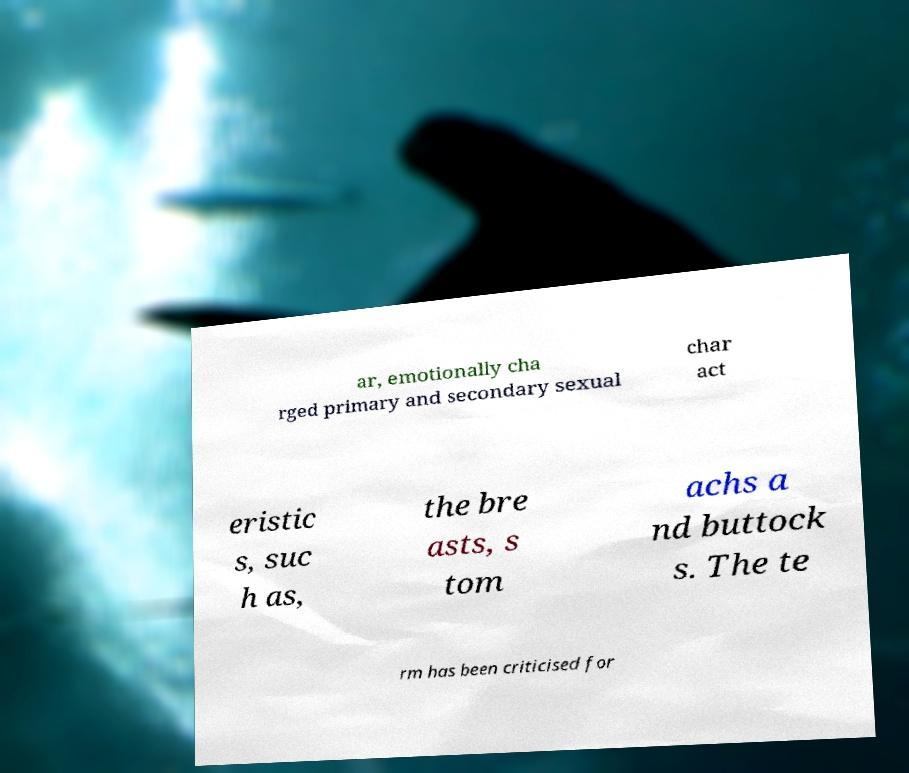For documentation purposes, I need the text within this image transcribed. Could you provide that? ar, emotionally cha rged primary and secondary sexual char act eristic s, suc h as, the bre asts, s tom achs a nd buttock s. The te rm has been criticised for 